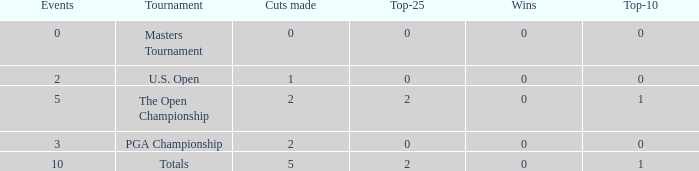What is the sum of top-10s for events with more than 0 wins? None. 